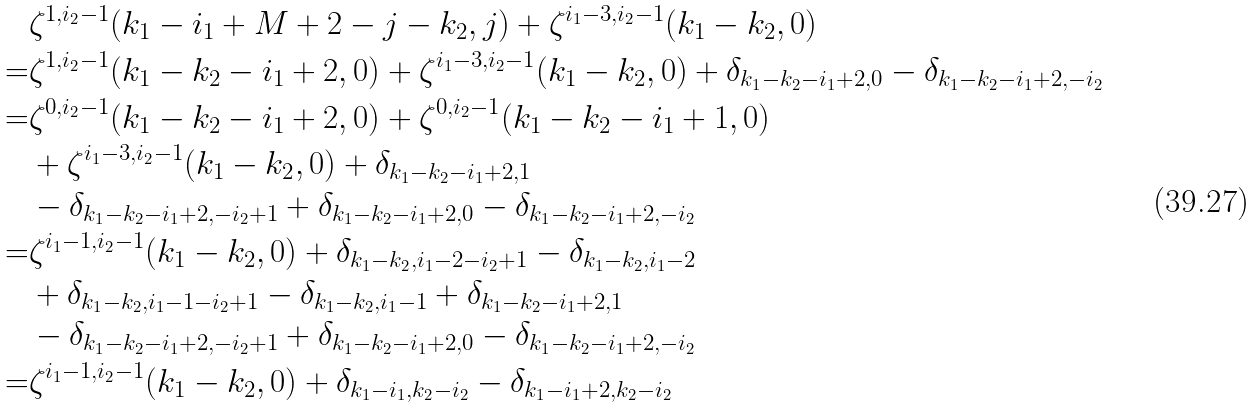<formula> <loc_0><loc_0><loc_500><loc_500>& \zeta ^ { 1 , i _ { 2 } - 1 } ( k _ { 1 } - i _ { 1 } + M + 2 - j - k _ { 2 } , j ) + \zeta ^ { i _ { 1 } - 3 , i _ { 2 } - 1 } ( k _ { 1 } - k _ { 2 } , 0 ) \\ = & \zeta ^ { 1 , i _ { 2 } - 1 } ( k _ { 1 } - k _ { 2 } - i _ { 1 } + 2 , 0 ) + \zeta ^ { i _ { 1 } - 3 , i _ { 2 } - 1 } ( k _ { 1 } - k _ { 2 } , 0 ) + \delta _ { k _ { 1 } - k _ { 2 } - i _ { 1 } + 2 , 0 } - \delta _ { k _ { 1 } - k _ { 2 } - i _ { 1 } + 2 , - i _ { 2 } } \\ = & \zeta ^ { 0 , i _ { 2 } - 1 } ( k _ { 1 } - k _ { 2 } - i _ { 1 } + 2 , 0 ) + \zeta ^ { 0 , i _ { 2 } - 1 } ( k _ { 1 } - k _ { 2 } - i _ { 1 } + 1 , 0 ) \\ & + \zeta ^ { i _ { 1 } - 3 , i _ { 2 } - 1 } ( k _ { 1 } - k _ { 2 } , 0 ) + \delta _ { k _ { 1 } - k _ { 2 } - i _ { 1 } + 2 , 1 } \\ & - \delta _ { k _ { 1 } - k _ { 2 } - i _ { 1 } + 2 , - i _ { 2 } + 1 } + \delta _ { k _ { 1 } - k _ { 2 } - i _ { 1 } + 2 , 0 } - \delta _ { k _ { 1 } - k _ { 2 } - i _ { 1 } + 2 , - i _ { 2 } } \\ = & \zeta ^ { i _ { 1 } - 1 , i _ { 2 } - 1 } ( k _ { 1 } - k _ { 2 } , 0 ) + \delta _ { k _ { 1 } - k _ { 2 } , i _ { 1 } - 2 - i _ { 2 } + 1 } - \delta _ { k _ { 1 } - k _ { 2 } , i _ { 1 } - 2 } \\ & + \delta _ { k _ { 1 } - k _ { 2 } , i _ { 1 } - 1 - i _ { 2 } + 1 } - \delta _ { k _ { 1 } - k _ { 2 } , i _ { 1 } - 1 } + \delta _ { k _ { 1 } - k _ { 2 } - i _ { 1 } + 2 , 1 } \\ & - \delta _ { k _ { 1 } - k _ { 2 } - i _ { 1 } + 2 , - i _ { 2 } + 1 } + \delta _ { k _ { 1 } - k _ { 2 } - i _ { 1 } + 2 , 0 } - \delta _ { k _ { 1 } - k _ { 2 } - i _ { 1 } + 2 , - i _ { 2 } } \\ = & \zeta ^ { i _ { 1 } - 1 , i _ { 2 } - 1 } ( k _ { 1 } - k _ { 2 } , 0 ) + \delta _ { k _ { 1 } - i _ { 1 } , k _ { 2 } - i _ { 2 } } - \delta _ { k _ { 1 } - i _ { 1 } + 2 , k _ { 2 } - i _ { 2 } } \\</formula> 